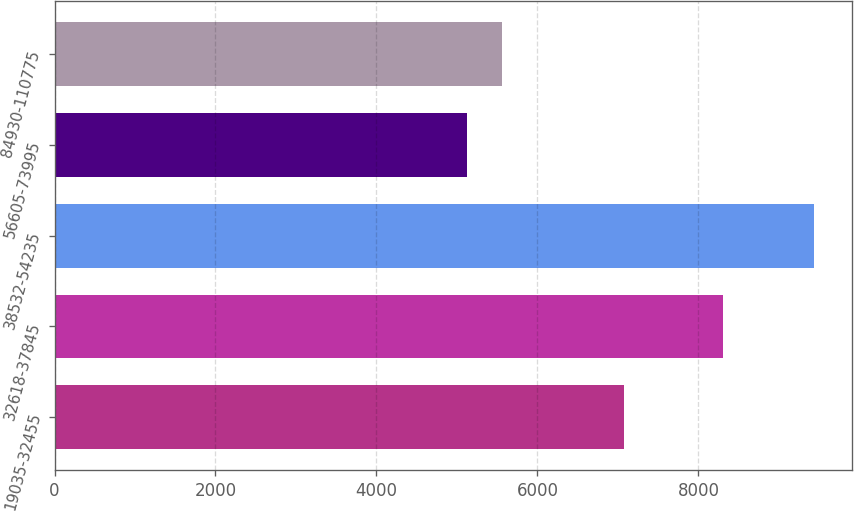Convert chart to OTSL. <chart><loc_0><loc_0><loc_500><loc_500><bar_chart><fcel>19035-32455<fcel>32618-37845<fcel>38532-54235<fcel>56605-73995<fcel>84930-110775<nl><fcel>7081<fcel>8300<fcel>9431<fcel>5129<fcel>5559.2<nl></chart> 